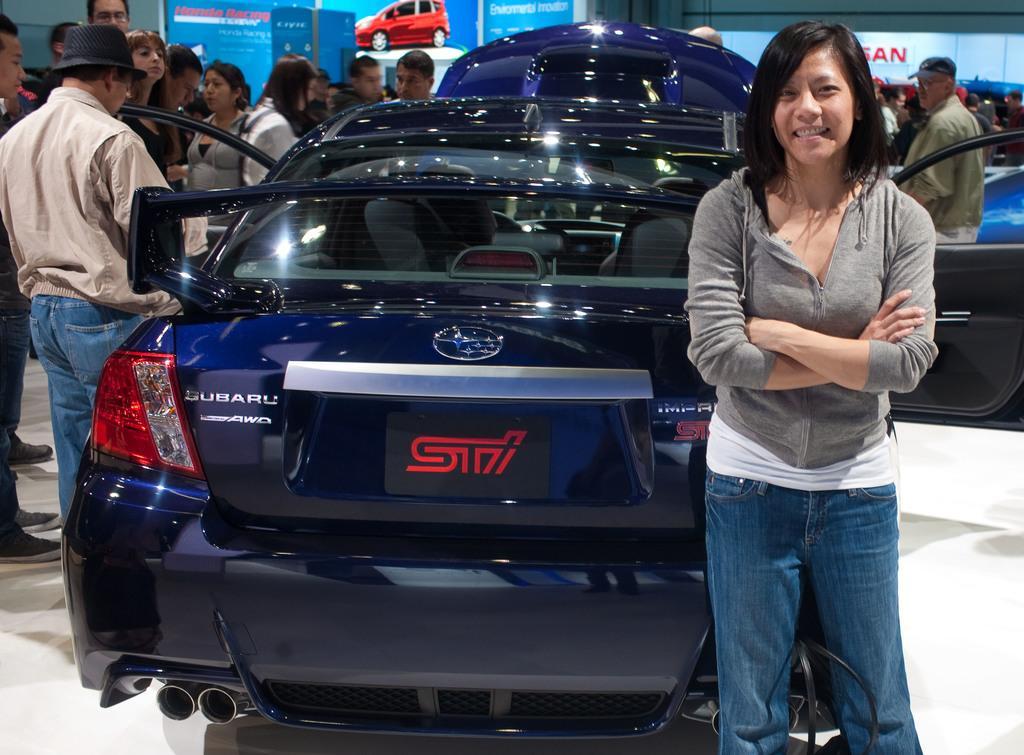How would you summarize this image in a sentence or two? On the right side of the image, we can see a woman is standing near the car and smiling. Background we can see a group of people are standing. Here we can see banners. At the bottom, there is a floor. 